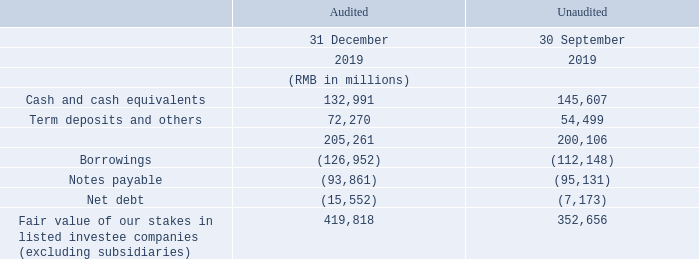As at 31 December 2019, the Group had net debt of RMB15,552 million, compared to net debt of RMB7,173 million as at 30 September 2019. The sequential increase in indebtedness mainly reflected payments for M&A initiatives and media contents, as well as the consolidation of indebtedness at Halti, partly offset by strong free cash flow generation.
As at 31 December 2019, the Group had net debt of RMB15,552 million, compared to net debt of RMB7,173 million as at 30 September 2019. The sequential increase in indebtedness mainly reflected payments for M&A initiatives and media contents, as well as the consolidation of indebtedness at Halti, partly offset by strong free cash flow generation.
For the fourth quarter of 2019, the Group had free cash flow of RMB37,896 million. This was a result of net cash flow generated from operating activities of RMB50,604 million, offset by payments for capital expenditure of RMB12,708 million.
What is the group's net debt as at 31 December 2019? Rmb15,552 million. What is the group's net debt as at 30 September 2019? Rmb7,173 million. What was the group's cash flow for the fourth quarter of 2019? Rmb37,896 million. What is the difference between cash and cash equivalents of 30 September and 31 December 2019?
Answer scale should be: million. 145,607-132,991
Answer: 12616. What is the change in borrowings between 31 December 2019 and 30 September 2019?
Answer scale should be: million. 126,952-112,148
Answer: 14804. What is the change in notes payable between 31 December 2019 and 30 September 2019?
Answer scale should be: million. 95,131-93,861
Answer: 1270. 